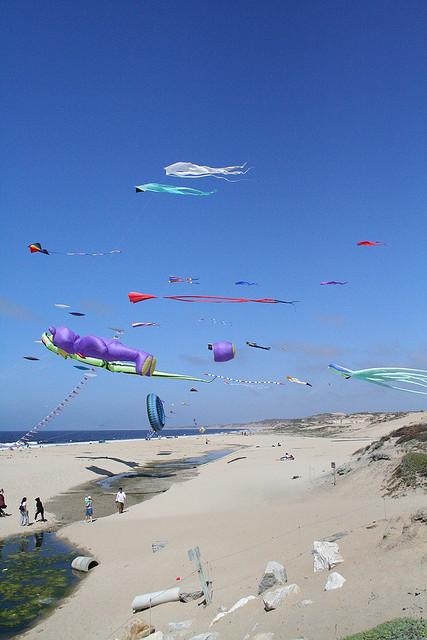What direction is the wind blowing? right 